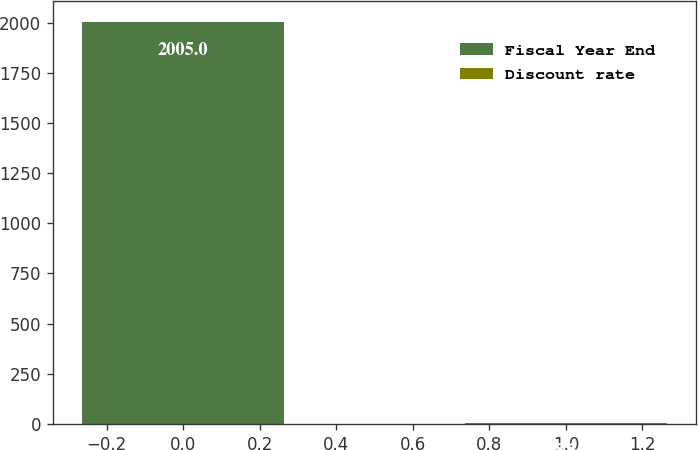<chart> <loc_0><loc_0><loc_500><loc_500><bar_chart><fcel>Fiscal Year End<fcel>Discount rate<nl><fcel>2005<fcel>5.5<nl></chart> 